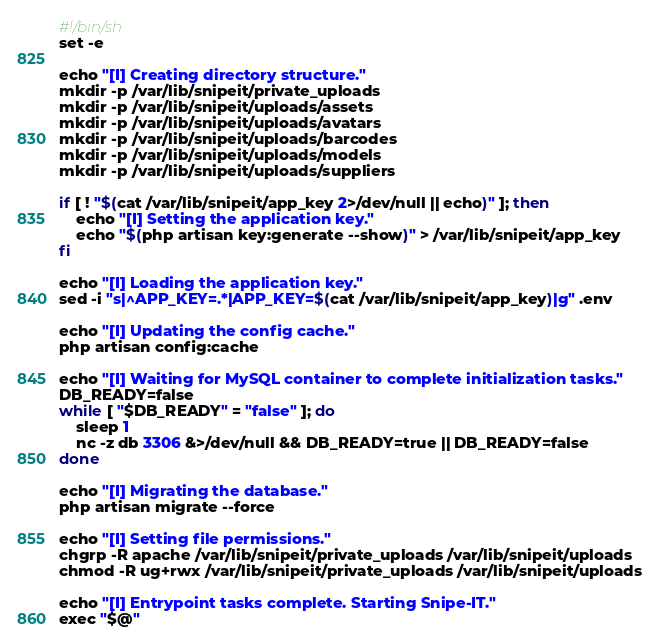<code> <loc_0><loc_0><loc_500><loc_500><_Bash_>#!/bin/sh
set -e

echo "[I] Creating directory structure."
mkdir -p /var/lib/snipeit/private_uploads
mkdir -p /var/lib/snipeit/uploads/assets
mkdir -p /var/lib/snipeit/uploads/avatars
mkdir -p /var/lib/snipeit/uploads/barcodes
mkdir -p /var/lib/snipeit/uploads/models
mkdir -p /var/lib/snipeit/uploads/suppliers

if [ ! "$(cat /var/lib/snipeit/app_key 2>/dev/null || echo)" ]; then
    echo "[I] Setting the application key."
    echo "$(php artisan key:generate --show)" > /var/lib/snipeit/app_key
fi

echo "[I] Loading the application key."
sed -i "s|^APP_KEY=.*|APP_KEY=$(cat /var/lib/snipeit/app_key)|g" .env

echo "[I] Updating the config cache."
php artisan config:cache

echo "[I] Waiting for MySQL container to complete initialization tasks."
DB_READY=false
while [ "$DB_READY" = "false" ]; do
    sleep 1
    nc -z db 3306 &>/dev/null && DB_READY=true || DB_READY=false
done

echo "[I] Migrating the database."
php artisan migrate --force

echo "[I] Setting file permissions."
chgrp -R apache /var/lib/snipeit/private_uploads /var/lib/snipeit/uploads
chmod -R ug+rwx /var/lib/snipeit/private_uploads /var/lib/snipeit/uploads

echo "[I] Entrypoint tasks complete. Starting Snipe-IT."
exec "$@"
</code> 